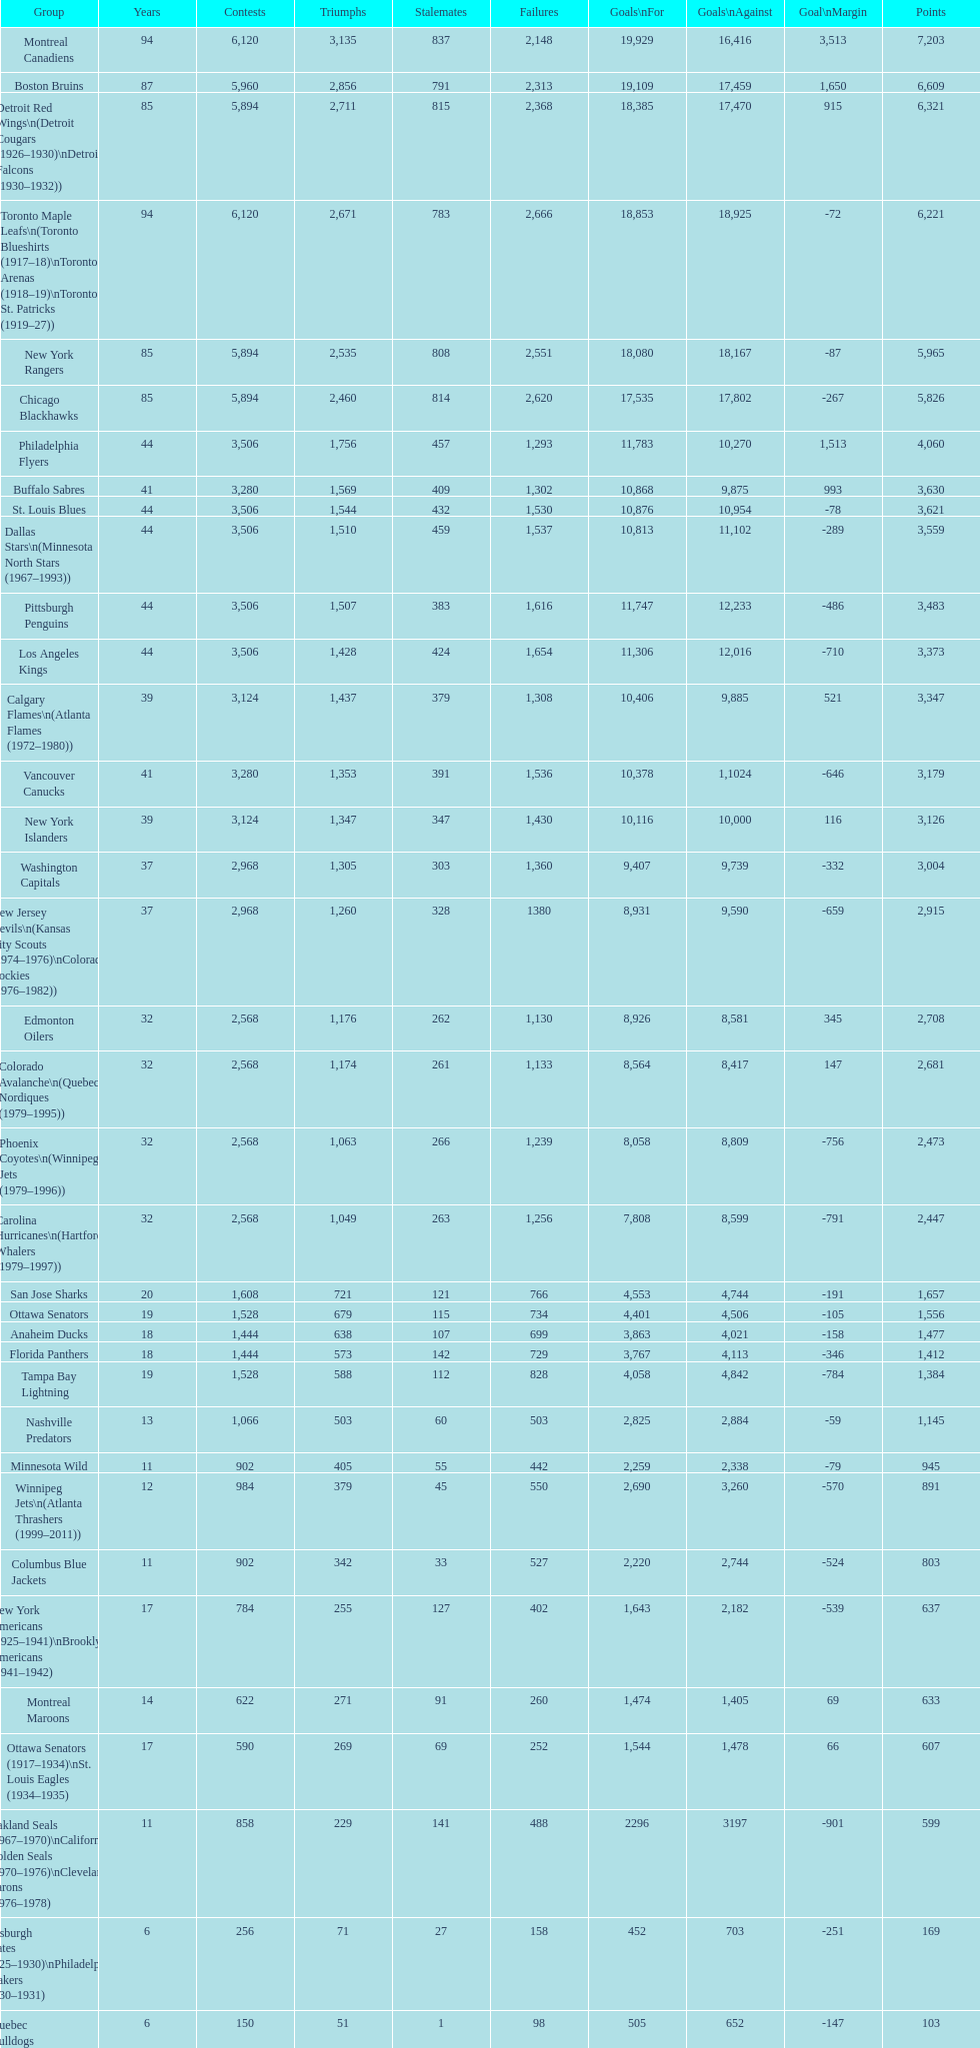How many losses do the st. louis blues have? 1,530. Help me parse the entirety of this table. {'header': ['Group', 'Years', 'Contests', 'Triumphs', 'Stalemates', 'Failures', 'Goals\\nFor', 'Goals\\nAgainst', 'Goal\\nMargin', 'Points'], 'rows': [['Montreal Canadiens', '94', '6,120', '3,135', '837', '2,148', '19,929', '16,416', '3,513', '7,203'], ['Boston Bruins', '87', '5,960', '2,856', '791', '2,313', '19,109', '17,459', '1,650', '6,609'], ['Detroit Red Wings\\n(Detroit Cougars (1926–1930)\\nDetroit Falcons (1930–1932))', '85', '5,894', '2,711', '815', '2,368', '18,385', '17,470', '915', '6,321'], ['Toronto Maple Leafs\\n(Toronto Blueshirts (1917–18)\\nToronto Arenas (1918–19)\\nToronto St. Patricks (1919–27))', '94', '6,120', '2,671', '783', '2,666', '18,853', '18,925', '-72', '6,221'], ['New York Rangers', '85', '5,894', '2,535', '808', '2,551', '18,080', '18,167', '-87', '5,965'], ['Chicago Blackhawks', '85', '5,894', '2,460', '814', '2,620', '17,535', '17,802', '-267', '5,826'], ['Philadelphia Flyers', '44', '3,506', '1,756', '457', '1,293', '11,783', '10,270', '1,513', '4,060'], ['Buffalo Sabres', '41', '3,280', '1,569', '409', '1,302', '10,868', '9,875', '993', '3,630'], ['St. Louis Blues', '44', '3,506', '1,544', '432', '1,530', '10,876', '10,954', '-78', '3,621'], ['Dallas Stars\\n(Minnesota North Stars (1967–1993))', '44', '3,506', '1,510', '459', '1,537', '10,813', '11,102', '-289', '3,559'], ['Pittsburgh Penguins', '44', '3,506', '1,507', '383', '1,616', '11,747', '12,233', '-486', '3,483'], ['Los Angeles Kings', '44', '3,506', '1,428', '424', '1,654', '11,306', '12,016', '-710', '3,373'], ['Calgary Flames\\n(Atlanta Flames (1972–1980))', '39', '3,124', '1,437', '379', '1,308', '10,406', '9,885', '521', '3,347'], ['Vancouver Canucks', '41', '3,280', '1,353', '391', '1,536', '10,378', '1,1024', '-646', '3,179'], ['New York Islanders', '39', '3,124', '1,347', '347', '1,430', '10,116', '10,000', '116', '3,126'], ['Washington Capitals', '37', '2,968', '1,305', '303', '1,360', '9,407', '9,739', '-332', '3,004'], ['New Jersey Devils\\n(Kansas City Scouts (1974–1976)\\nColorado Rockies (1976–1982))', '37', '2,968', '1,260', '328', '1380', '8,931', '9,590', '-659', '2,915'], ['Edmonton Oilers', '32', '2,568', '1,176', '262', '1,130', '8,926', '8,581', '345', '2,708'], ['Colorado Avalanche\\n(Quebec Nordiques (1979–1995))', '32', '2,568', '1,174', '261', '1,133', '8,564', '8,417', '147', '2,681'], ['Phoenix Coyotes\\n(Winnipeg Jets (1979–1996))', '32', '2,568', '1,063', '266', '1,239', '8,058', '8,809', '-756', '2,473'], ['Carolina Hurricanes\\n(Hartford Whalers (1979–1997))', '32', '2,568', '1,049', '263', '1,256', '7,808', '8,599', '-791', '2,447'], ['San Jose Sharks', '20', '1,608', '721', '121', '766', '4,553', '4,744', '-191', '1,657'], ['Ottawa Senators', '19', '1,528', '679', '115', '734', '4,401', '4,506', '-105', '1,556'], ['Anaheim Ducks', '18', '1,444', '638', '107', '699', '3,863', '4,021', '-158', '1,477'], ['Florida Panthers', '18', '1,444', '573', '142', '729', '3,767', '4,113', '-346', '1,412'], ['Tampa Bay Lightning', '19', '1,528', '588', '112', '828', '4,058', '4,842', '-784', '1,384'], ['Nashville Predators', '13', '1,066', '503', '60', '503', '2,825', '2,884', '-59', '1,145'], ['Minnesota Wild', '11', '902', '405', '55', '442', '2,259', '2,338', '-79', '945'], ['Winnipeg Jets\\n(Atlanta Thrashers (1999–2011))', '12', '984', '379', '45', '550', '2,690', '3,260', '-570', '891'], ['Columbus Blue Jackets', '11', '902', '342', '33', '527', '2,220', '2,744', '-524', '803'], ['New York Americans (1925–1941)\\nBrooklyn Americans (1941–1942)', '17', '784', '255', '127', '402', '1,643', '2,182', '-539', '637'], ['Montreal Maroons', '14', '622', '271', '91', '260', '1,474', '1,405', '69', '633'], ['Ottawa Senators (1917–1934)\\nSt. Louis Eagles (1934–1935)', '17', '590', '269', '69', '252', '1,544', '1,478', '66', '607'], ['Oakland Seals (1967–1970)\\nCalifornia Golden Seals (1970–1976)\\nCleveland Barons (1976–1978)', '11', '858', '229', '141', '488', '2296', '3197', '-901', '599'], ['Pittsburgh Pirates (1925–1930)\\nPhiladelphia Quakers (1930–1931)', '6', '256', '71', '27', '158', '452', '703', '-251', '169'], ['Quebec Bulldogs (1919–1920)\\nHamilton Tigers (1920–1925)', '6', '150', '51', '1', '98', '505', '652', '-147', '103'], ['Montreal Wanderers', '1', '6', '1', '0', '5', '17', '35', '-18', '2']]} 